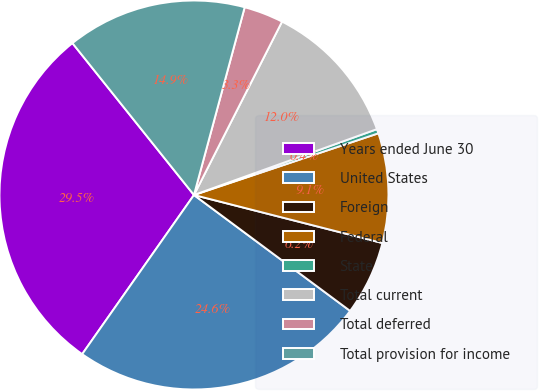<chart> <loc_0><loc_0><loc_500><loc_500><pie_chart><fcel>Years ended June 30<fcel>United States<fcel>Foreign<fcel>Federal<fcel>State<fcel>Total current<fcel>Total deferred<fcel>Total provision for income<nl><fcel>29.51%<fcel>24.58%<fcel>6.19%<fcel>9.11%<fcel>0.36%<fcel>12.02%<fcel>3.28%<fcel>14.94%<nl></chart> 